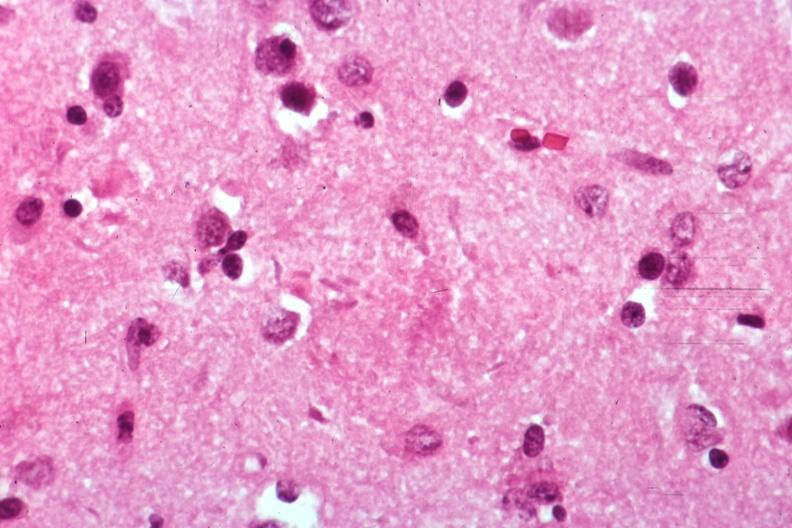s atypical appearing immunoblastic cells near splenic arteriole man present?
Answer the question using a single word or phrase. No 